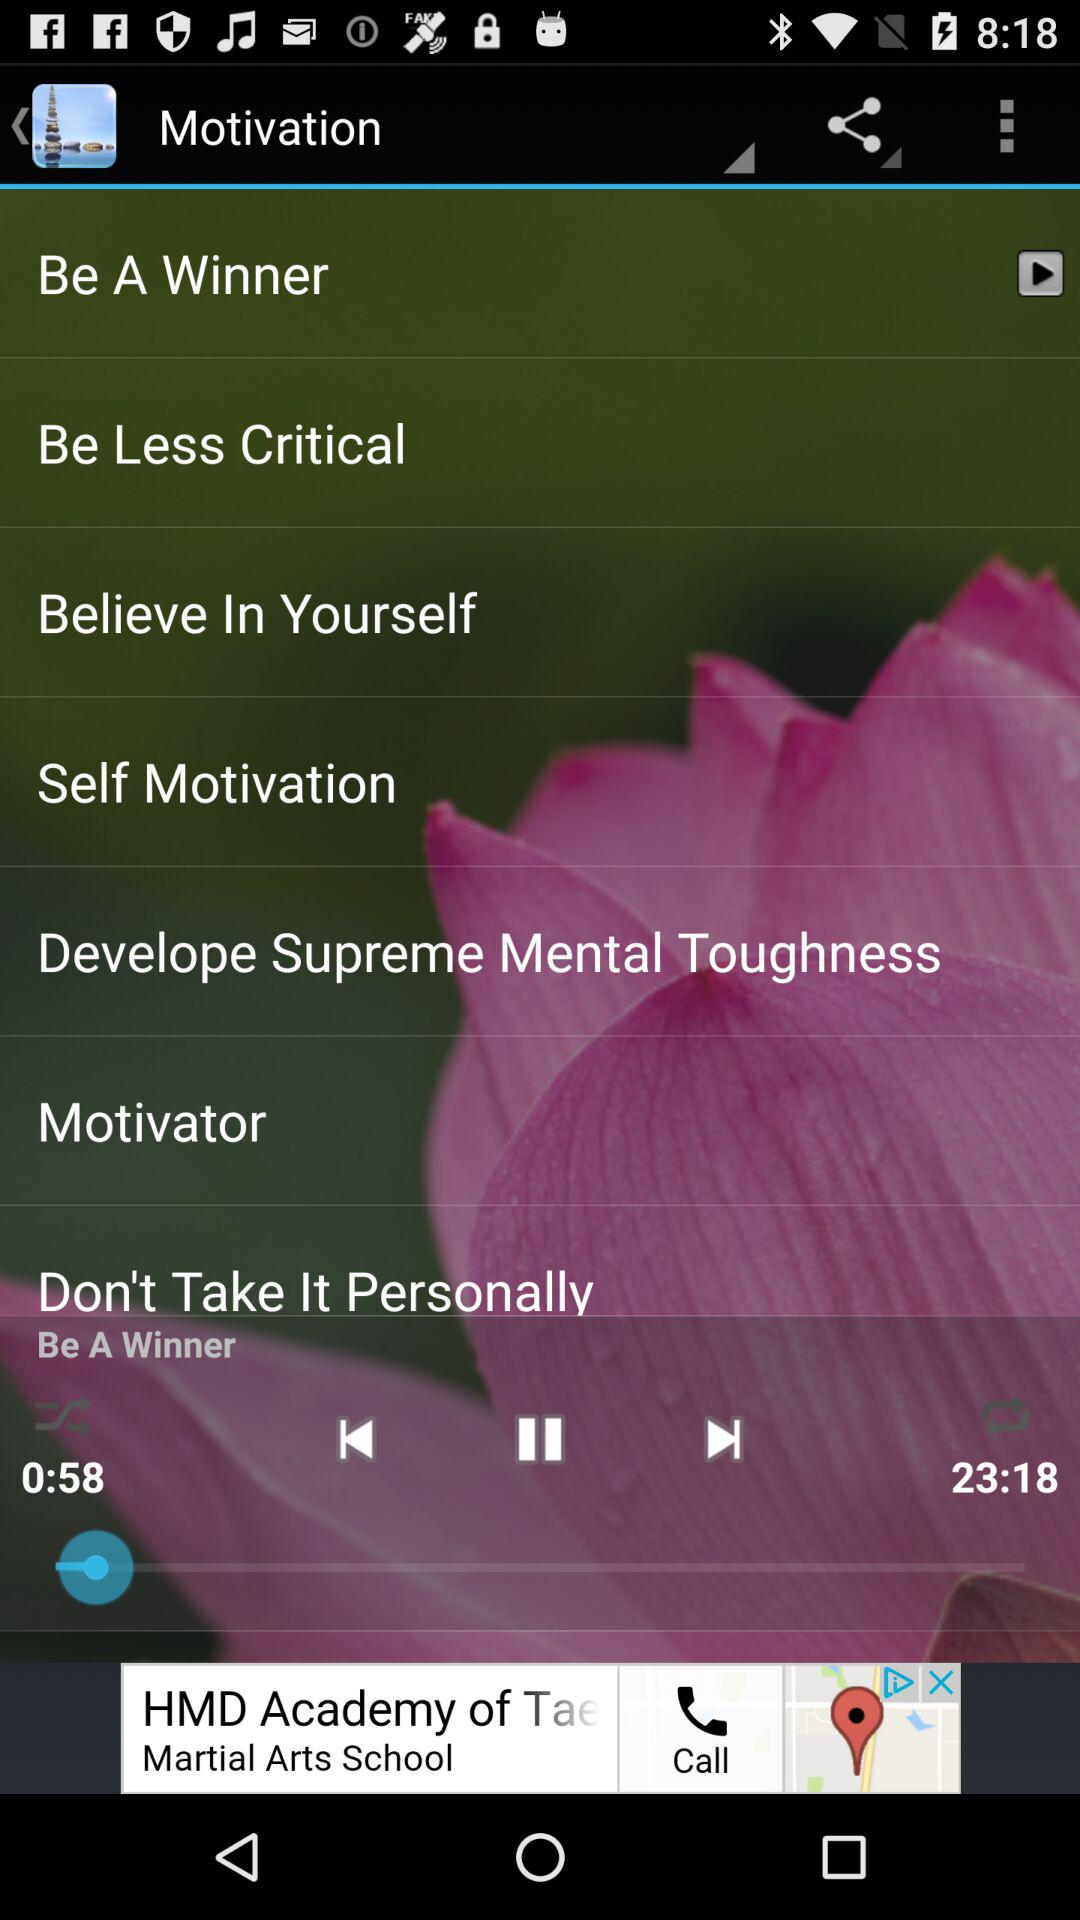How much of the "Be A Winner" music has elapsed? There have been 58 seconds elapsed. 